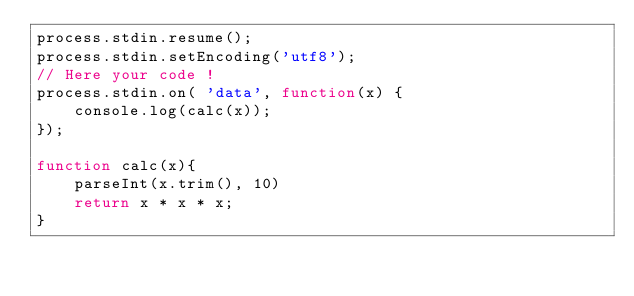Convert code to text. <code><loc_0><loc_0><loc_500><loc_500><_JavaScript_>process.stdin.resume();
process.stdin.setEncoding('utf8');
// Here your code !
process.stdin.on( 'data', function(x) {
    console.log(calc(x));
});

function calc(x){
    parseInt(x.trim(), 10)
    return x * x * x;
}</code> 